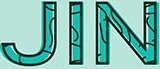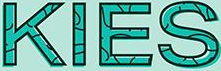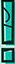Transcribe the words shown in these images in order, separated by a semicolon. JIN; KIES; ! 